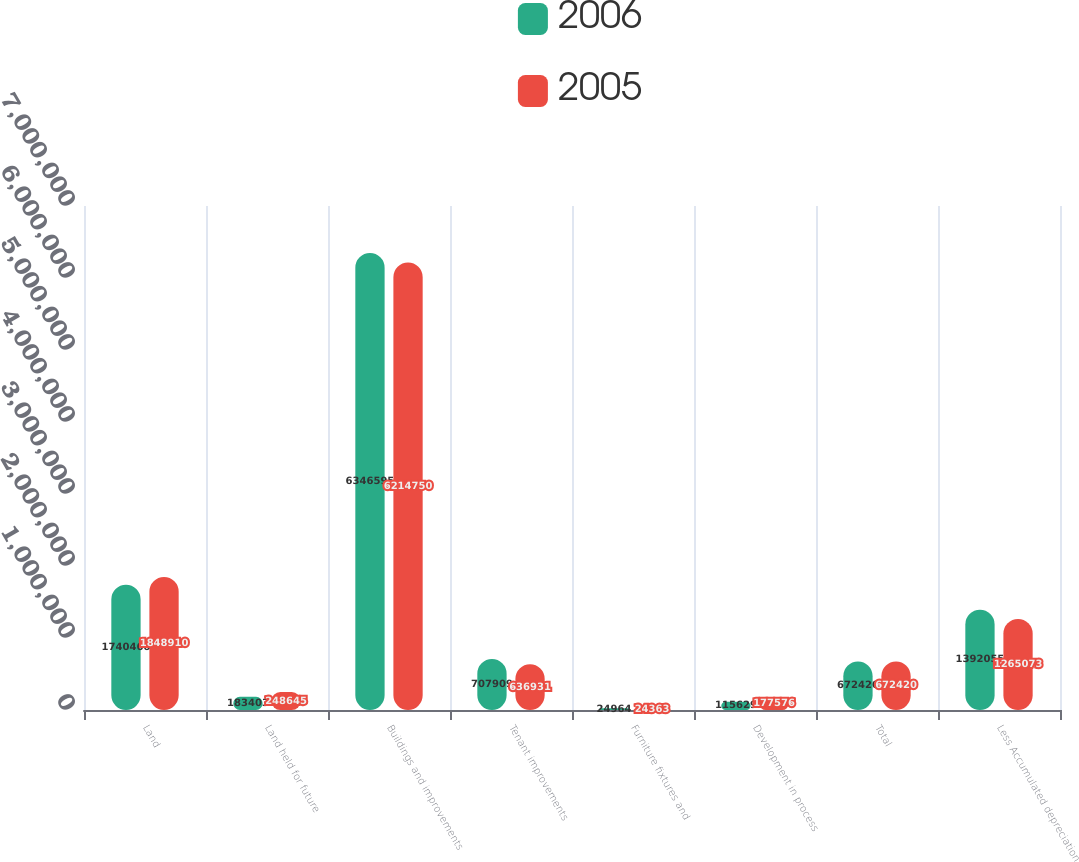<chart> <loc_0><loc_0><loc_500><loc_500><stacked_bar_chart><ecel><fcel>Land<fcel>Land held for future<fcel>Buildings and improvements<fcel>Tenant improvements<fcel>Furniture fixtures and<fcel>Development in process<fcel>Total<fcel>Less Accumulated depreciation<nl><fcel>2006<fcel>1.74047e+06<fcel>183403<fcel>6.3466e+06<fcel>707909<fcel>24964<fcel>115629<fcel>672420<fcel>1.39206e+06<nl><fcel>2005<fcel>1.84891e+06<fcel>248645<fcel>6.21475e+06<fcel>636931<fcel>24363<fcel>177576<fcel>672420<fcel>1.26507e+06<nl></chart> 